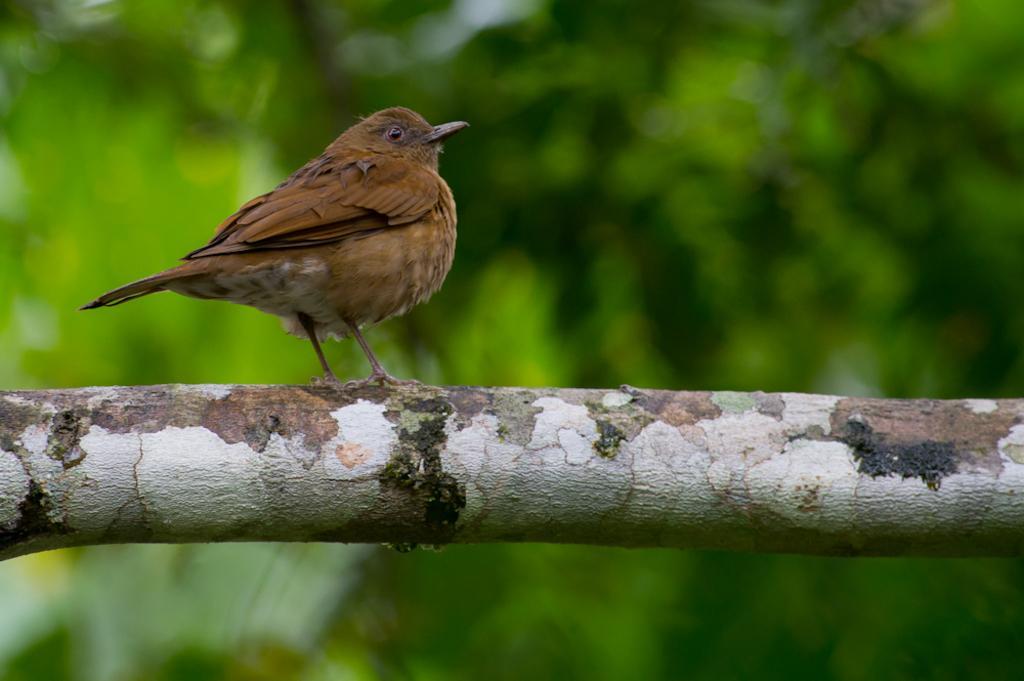Please provide a concise description of this image. We can see bird on the wooden surface. In the background it is blur and green. 